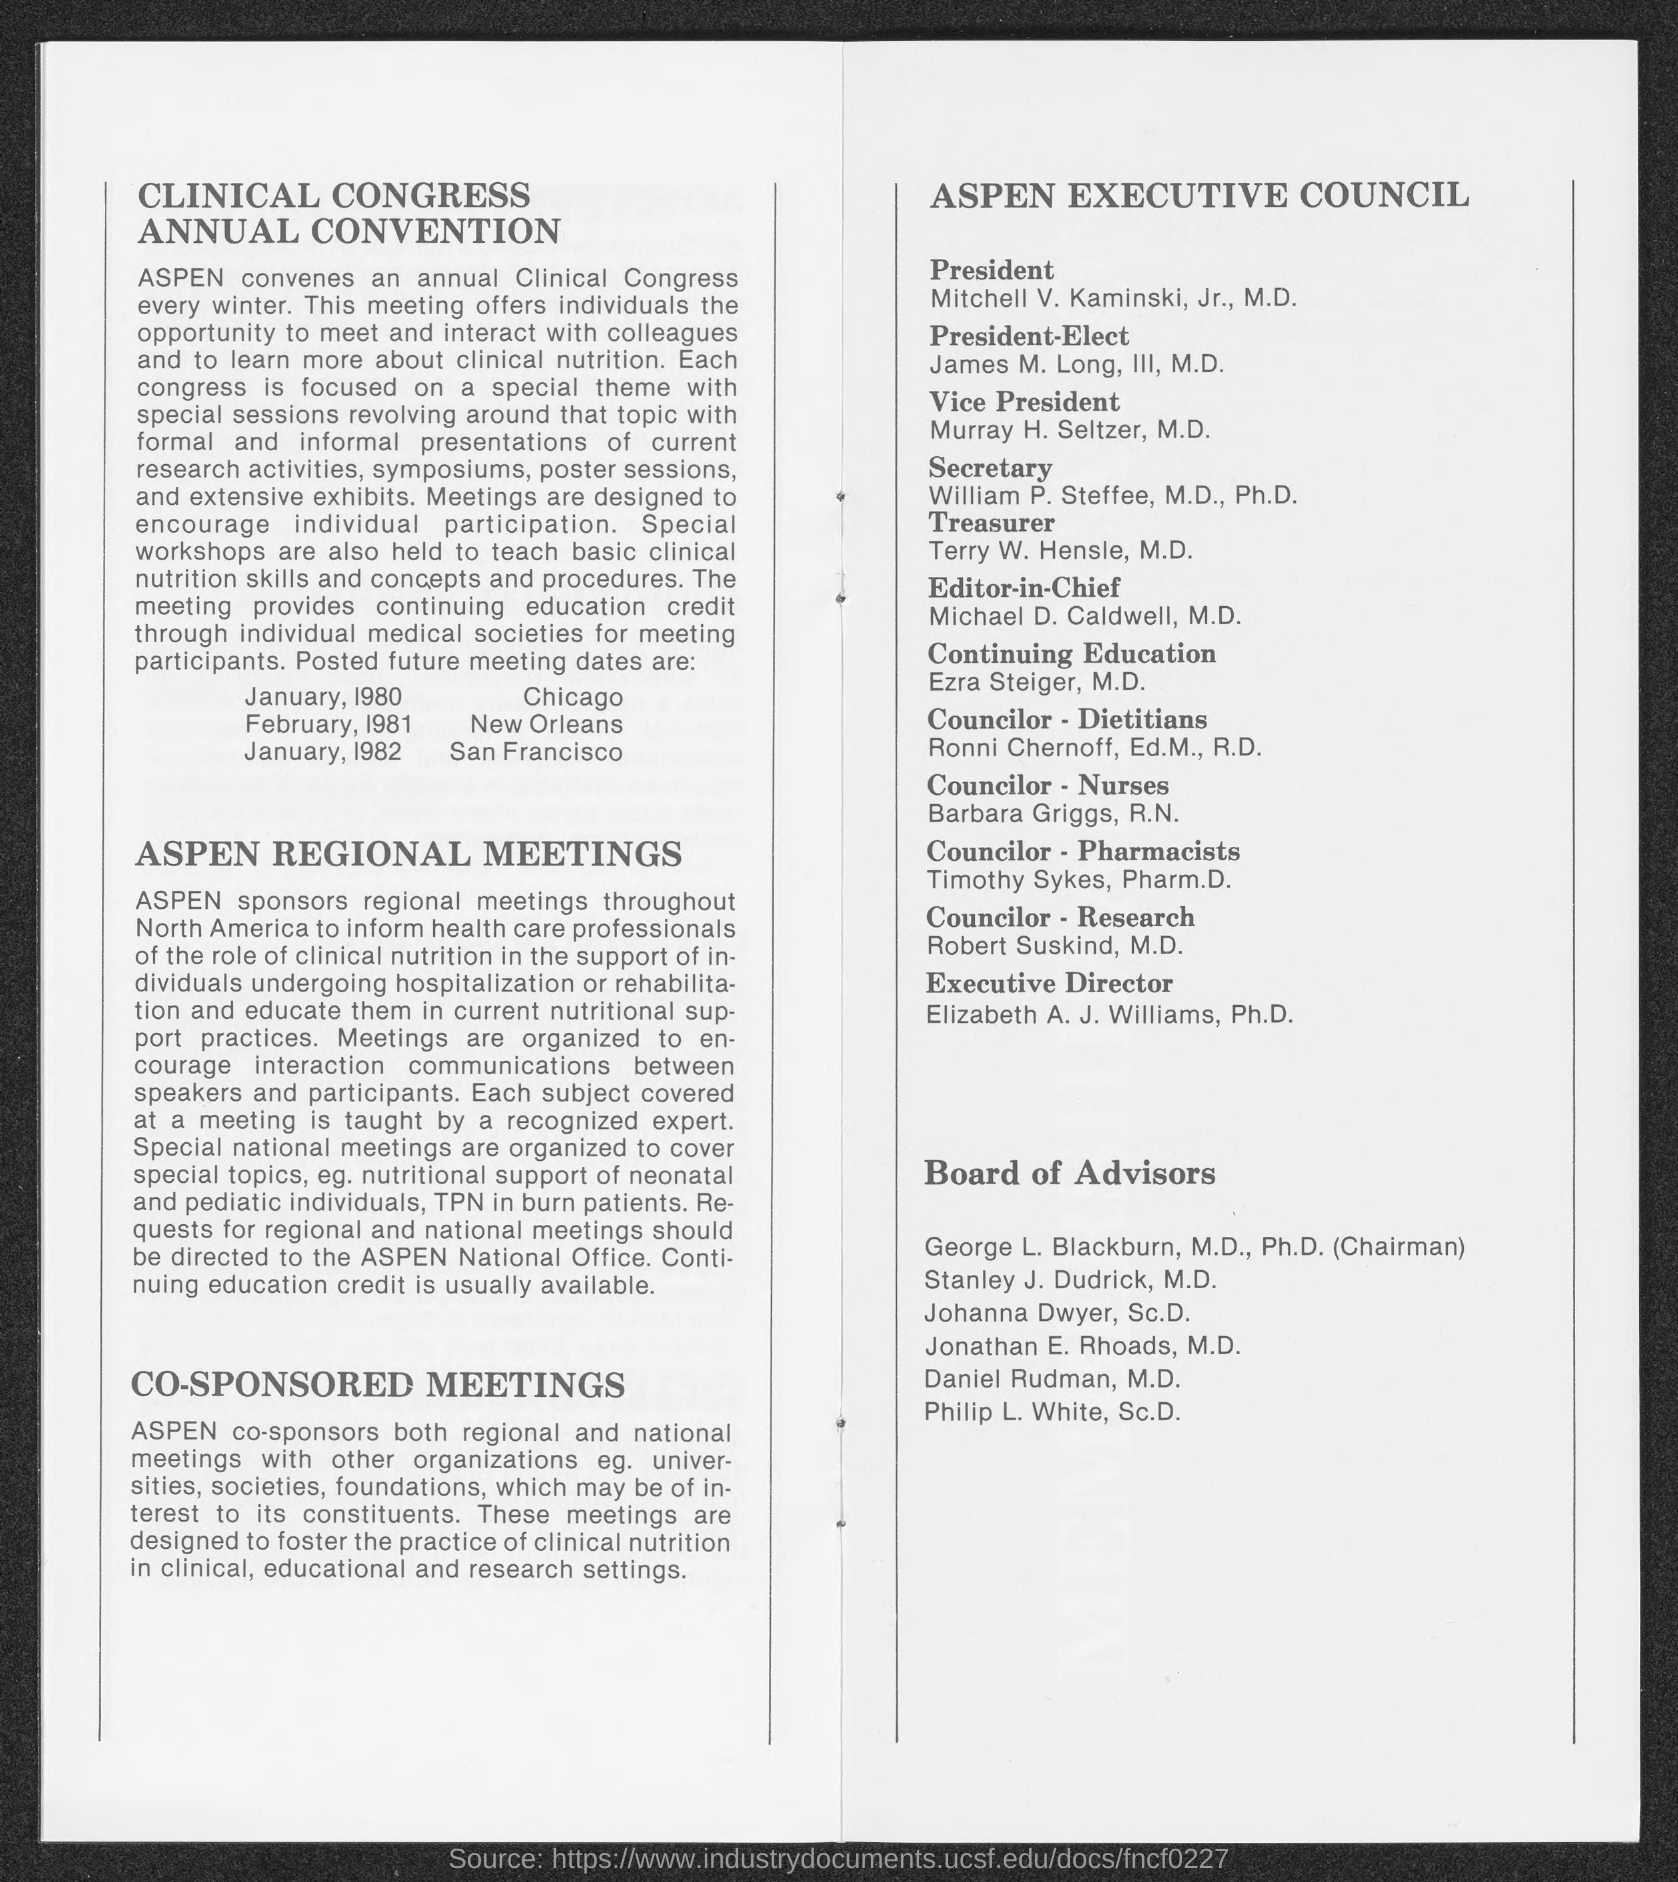Who is the President of ASPEN Executive Council?
Your response must be concise. Mitchell V. Kaminski, Jr., M.D. Who is the Vice President of ASPEN Executive Council?
Ensure brevity in your answer.  Murray H. Seltzer, M.D. Who is the secretary of ASPEN Executive Council?
Offer a very short reply. William P. Steffee. When is the ASPEN meeting scheduled in Chicago?
Offer a terse response. January, 1980. Where is the ASPEN meeting to be held in February 1981?
Offer a terse response. New Orleans. Where is the ASPEN meeting to be held in January 1982?
Provide a succinct answer. San Francisco. 